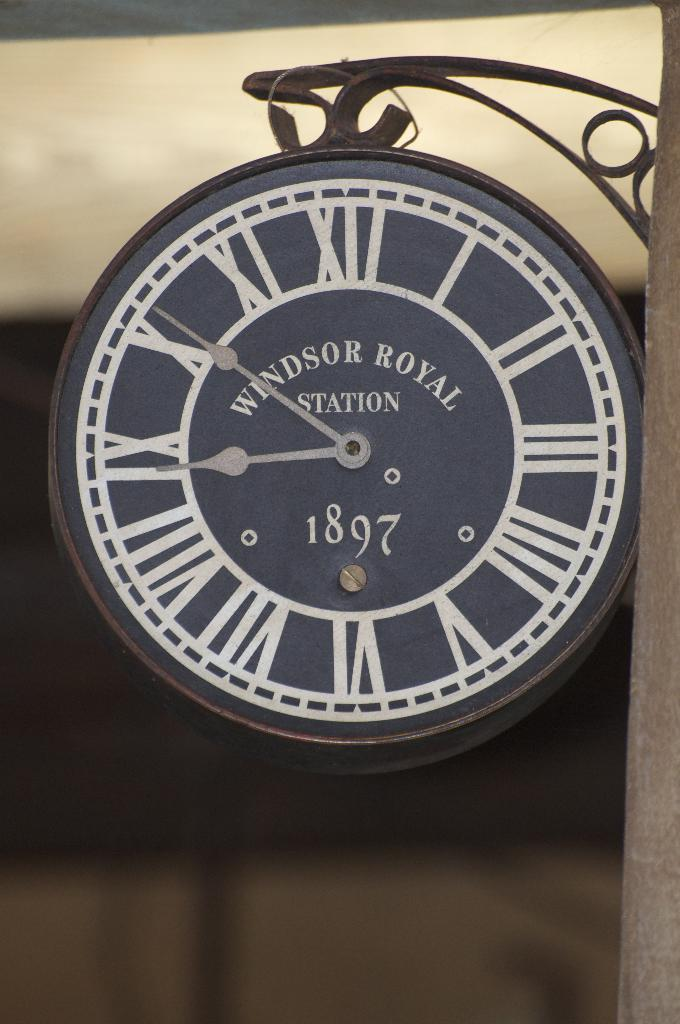<image>
Give a short and clear explanation of the subsequent image. A clock that says Windsor Royal Station on the face of it. 